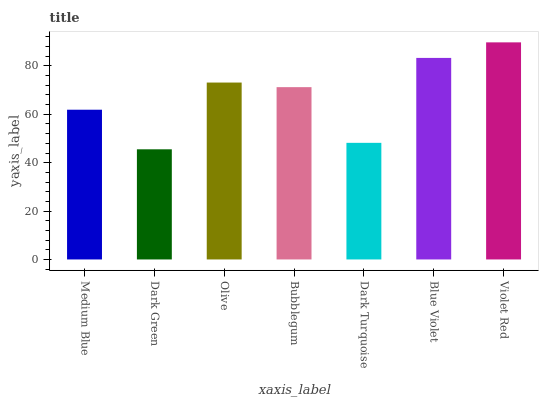Is Olive the minimum?
Answer yes or no. No. Is Olive the maximum?
Answer yes or no. No. Is Olive greater than Dark Green?
Answer yes or no. Yes. Is Dark Green less than Olive?
Answer yes or no. Yes. Is Dark Green greater than Olive?
Answer yes or no. No. Is Olive less than Dark Green?
Answer yes or no. No. Is Bubblegum the high median?
Answer yes or no. Yes. Is Bubblegum the low median?
Answer yes or no. Yes. Is Dark Green the high median?
Answer yes or no. No. Is Blue Violet the low median?
Answer yes or no. No. 